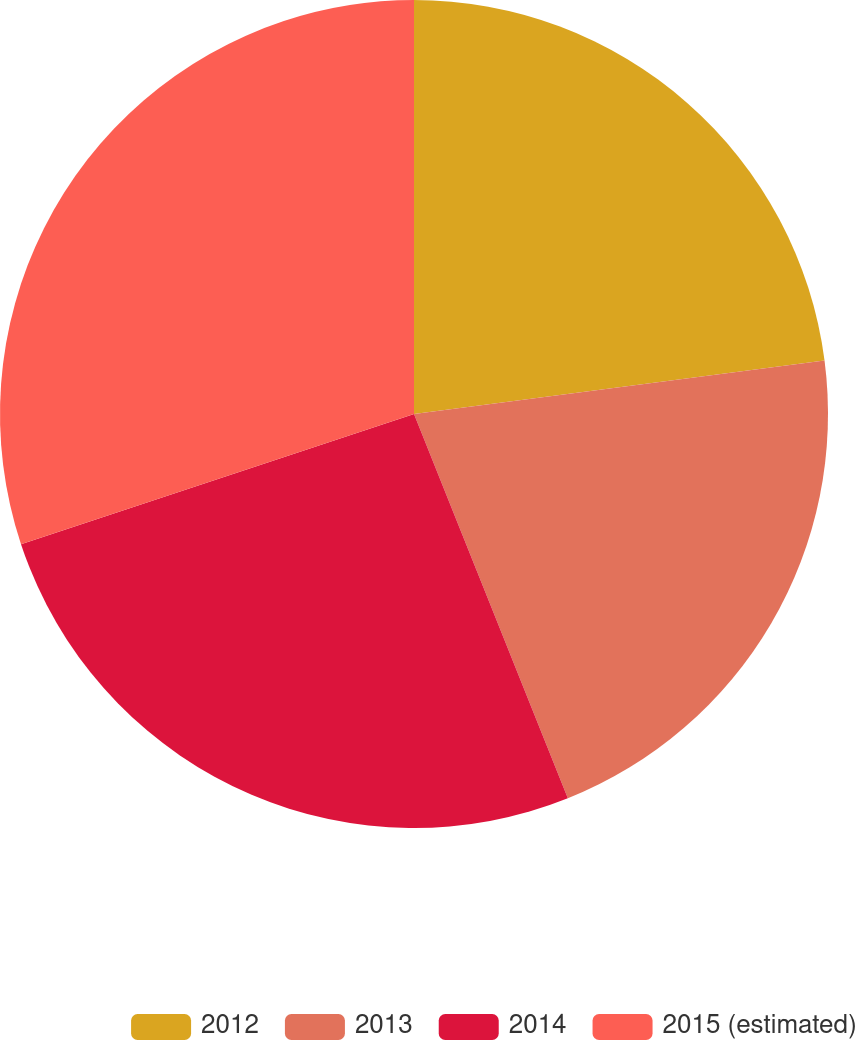Convert chart to OTSL. <chart><loc_0><loc_0><loc_500><loc_500><pie_chart><fcel>2012<fcel>2013<fcel>2014<fcel>2015 (estimated)<nl><fcel>22.94%<fcel>21.0%<fcel>25.97%<fcel>30.09%<nl></chart> 